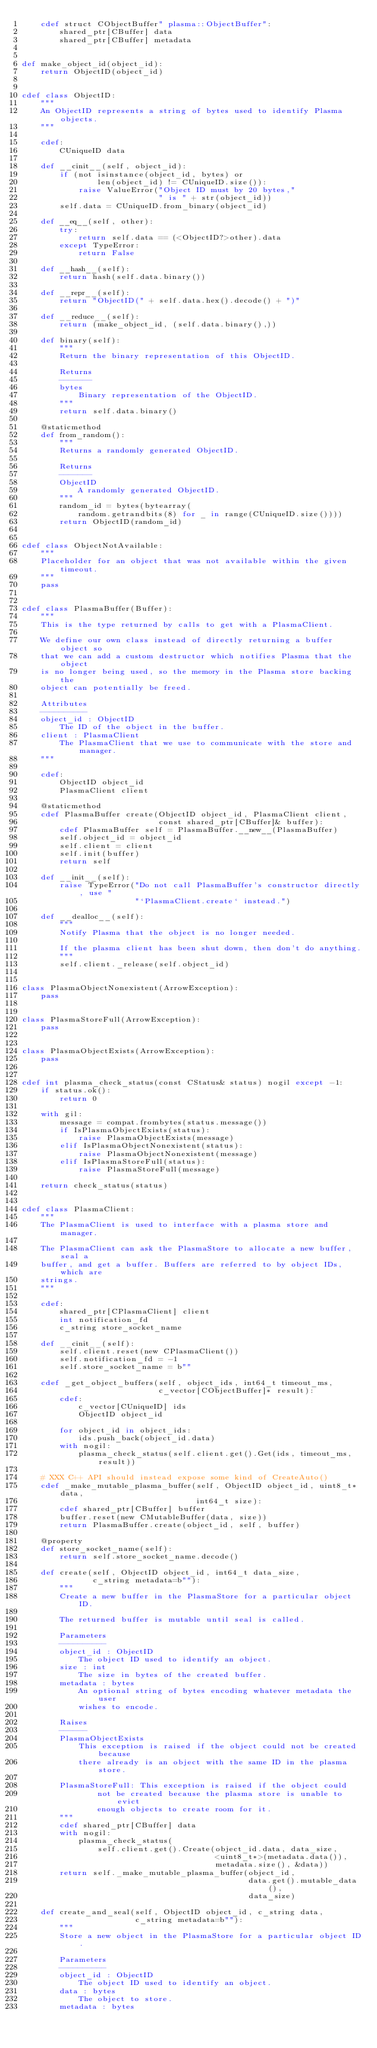<code> <loc_0><loc_0><loc_500><loc_500><_Cython_>    cdef struct CObjectBuffer" plasma::ObjectBuffer":
        shared_ptr[CBuffer] data
        shared_ptr[CBuffer] metadata


def make_object_id(object_id):
    return ObjectID(object_id)


cdef class ObjectID:
    """
    An ObjectID represents a string of bytes used to identify Plasma objects.
    """

    cdef:
        CUniqueID data

    def __cinit__(self, object_id):
        if (not isinstance(object_id, bytes) or
                len(object_id) != CUniqueID.size()):
            raise ValueError("Object ID must by 20 bytes,"
                             " is " + str(object_id))
        self.data = CUniqueID.from_binary(object_id)

    def __eq__(self, other):
        try:
            return self.data == (<ObjectID?>other).data
        except TypeError:
            return False

    def __hash__(self):
        return hash(self.data.binary())

    def __repr__(self):
        return "ObjectID(" + self.data.hex().decode() + ")"

    def __reduce__(self):
        return (make_object_id, (self.data.binary(),))

    def binary(self):
        """
        Return the binary representation of this ObjectID.

        Returns
        -------
        bytes
            Binary representation of the ObjectID.
        """
        return self.data.binary()

    @staticmethod
    def from_random():
        """
        Returns a randomly generated ObjectID.

        Returns
        -------
        ObjectID
            A randomly generated ObjectID.
        """
        random_id = bytes(bytearray(
            random.getrandbits(8) for _ in range(CUniqueID.size())))
        return ObjectID(random_id)


cdef class ObjectNotAvailable:
    """
    Placeholder for an object that was not available within the given timeout.
    """
    pass


cdef class PlasmaBuffer(Buffer):
    """
    This is the type returned by calls to get with a PlasmaClient.

    We define our own class instead of directly returning a buffer object so
    that we can add a custom destructor which notifies Plasma that the object
    is no longer being used, so the memory in the Plasma store backing the
    object can potentially be freed.

    Attributes
    ----------
    object_id : ObjectID
        The ID of the object in the buffer.
    client : PlasmaClient
        The PlasmaClient that we use to communicate with the store and manager.
    """

    cdef:
        ObjectID object_id
        PlasmaClient client

    @staticmethod
    cdef PlasmaBuffer create(ObjectID object_id, PlasmaClient client,
                             const shared_ptr[CBuffer]& buffer):
        cdef PlasmaBuffer self = PlasmaBuffer.__new__(PlasmaBuffer)
        self.object_id = object_id
        self.client = client
        self.init(buffer)
        return self

    def __init__(self):
        raise TypeError("Do not call PlasmaBuffer's constructor directly, use "
                        "`PlasmaClient.create` instead.")

    def __dealloc__(self):
        """
        Notify Plasma that the object is no longer needed.

        If the plasma client has been shut down, then don't do anything.
        """
        self.client._release(self.object_id)


class PlasmaObjectNonexistent(ArrowException):
    pass


class PlasmaStoreFull(ArrowException):
    pass


class PlasmaObjectExists(ArrowException):
    pass


cdef int plasma_check_status(const CStatus& status) nogil except -1:
    if status.ok():
        return 0

    with gil:
        message = compat.frombytes(status.message())
        if IsPlasmaObjectExists(status):
            raise PlasmaObjectExists(message)
        elif IsPlasmaObjectNonexistent(status):
            raise PlasmaObjectNonexistent(message)
        elif IsPlasmaStoreFull(status):
            raise PlasmaStoreFull(message)

    return check_status(status)


cdef class PlasmaClient:
    """
    The PlasmaClient is used to interface with a plasma store and manager.

    The PlasmaClient can ask the PlasmaStore to allocate a new buffer, seal a
    buffer, and get a buffer. Buffers are referred to by object IDs, which are
    strings.
    """

    cdef:
        shared_ptr[CPlasmaClient] client
        int notification_fd
        c_string store_socket_name

    def __cinit__(self):
        self.client.reset(new CPlasmaClient())
        self.notification_fd = -1
        self.store_socket_name = b""

    cdef _get_object_buffers(self, object_ids, int64_t timeout_ms,
                             c_vector[CObjectBuffer]* result):
        cdef:
            c_vector[CUniqueID] ids
            ObjectID object_id

        for object_id in object_ids:
            ids.push_back(object_id.data)
        with nogil:
            plasma_check_status(self.client.get().Get(ids, timeout_ms, result))

    # XXX C++ API should instead expose some kind of CreateAuto()
    cdef _make_mutable_plasma_buffer(self, ObjectID object_id, uint8_t* data,
                                     int64_t size):
        cdef shared_ptr[CBuffer] buffer
        buffer.reset(new CMutableBuffer(data, size))
        return PlasmaBuffer.create(object_id, self, buffer)

    @property
    def store_socket_name(self):
        return self.store_socket_name.decode()

    def create(self, ObjectID object_id, int64_t data_size,
               c_string metadata=b""):
        """
        Create a new buffer in the PlasmaStore for a particular object ID.

        The returned buffer is mutable until seal is called.

        Parameters
        ----------
        object_id : ObjectID
            The object ID used to identify an object.
        size : int
            The size in bytes of the created buffer.
        metadata : bytes
            An optional string of bytes encoding whatever metadata the user
            wishes to encode.

        Raises
        ------
        PlasmaObjectExists
            This exception is raised if the object could not be created because
            there already is an object with the same ID in the plasma store.

        PlasmaStoreFull: This exception is raised if the object could
                not be created because the plasma store is unable to evict
                enough objects to create room for it.
        """
        cdef shared_ptr[CBuffer] data
        with nogil:
            plasma_check_status(
                self.client.get().Create(object_id.data, data_size,
                                         <uint8_t*>(metadata.data()),
                                         metadata.size(), &data))
        return self._make_mutable_plasma_buffer(object_id,
                                                data.get().mutable_data(),
                                                data_size)

    def create_and_seal(self, ObjectID object_id, c_string data,
                        c_string metadata=b""):
        """
        Store a new object in the PlasmaStore for a particular object ID.

        Parameters
        ----------
        object_id : ObjectID
            The object ID used to identify an object.
        data : bytes
            The object to store.
        metadata : bytes</code> 